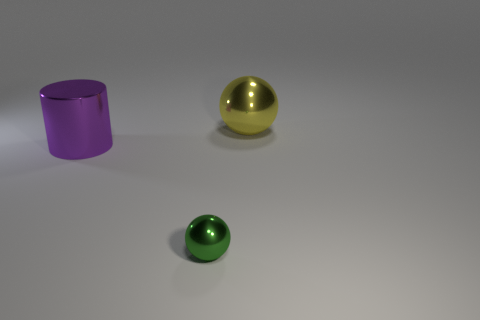How many large blue shiny cylinders are there?
Give a very brief answer. 0. What material is the yellow ball that is the same size as the cylinder?
Your response must be concise. Metal. There is a thing behind the purple metal cylinder; is its size the same as the big metallic cylinder?
Ensure brevity in your answer.  Yes. Is the shape of the thing in front of the big cylinder the same as  the large yellow shiny object?
Your answer should be very brief. Yes. How many objects are green things or objects in front of the purple cylinder?
Offer a terse response. 1. Are there fewer big yellow metallic balls than large yellow rubber cylinders?
Provide a succinct answer. No. Is the number of metallic balls greater than the number of large cylinders?
Ensure brevity in your answer.  Yes. What number of other things are made of the same material as the cylinder?
Make the answer very short. 2. There is a metal sphere that is left of the shiny sphere right of the small thing; what number of large yellow balls are in front of it?
Keep it short and to the point. 0. How many shiny objects are either big green objects or large things?
Your answer should be compact. 2. 